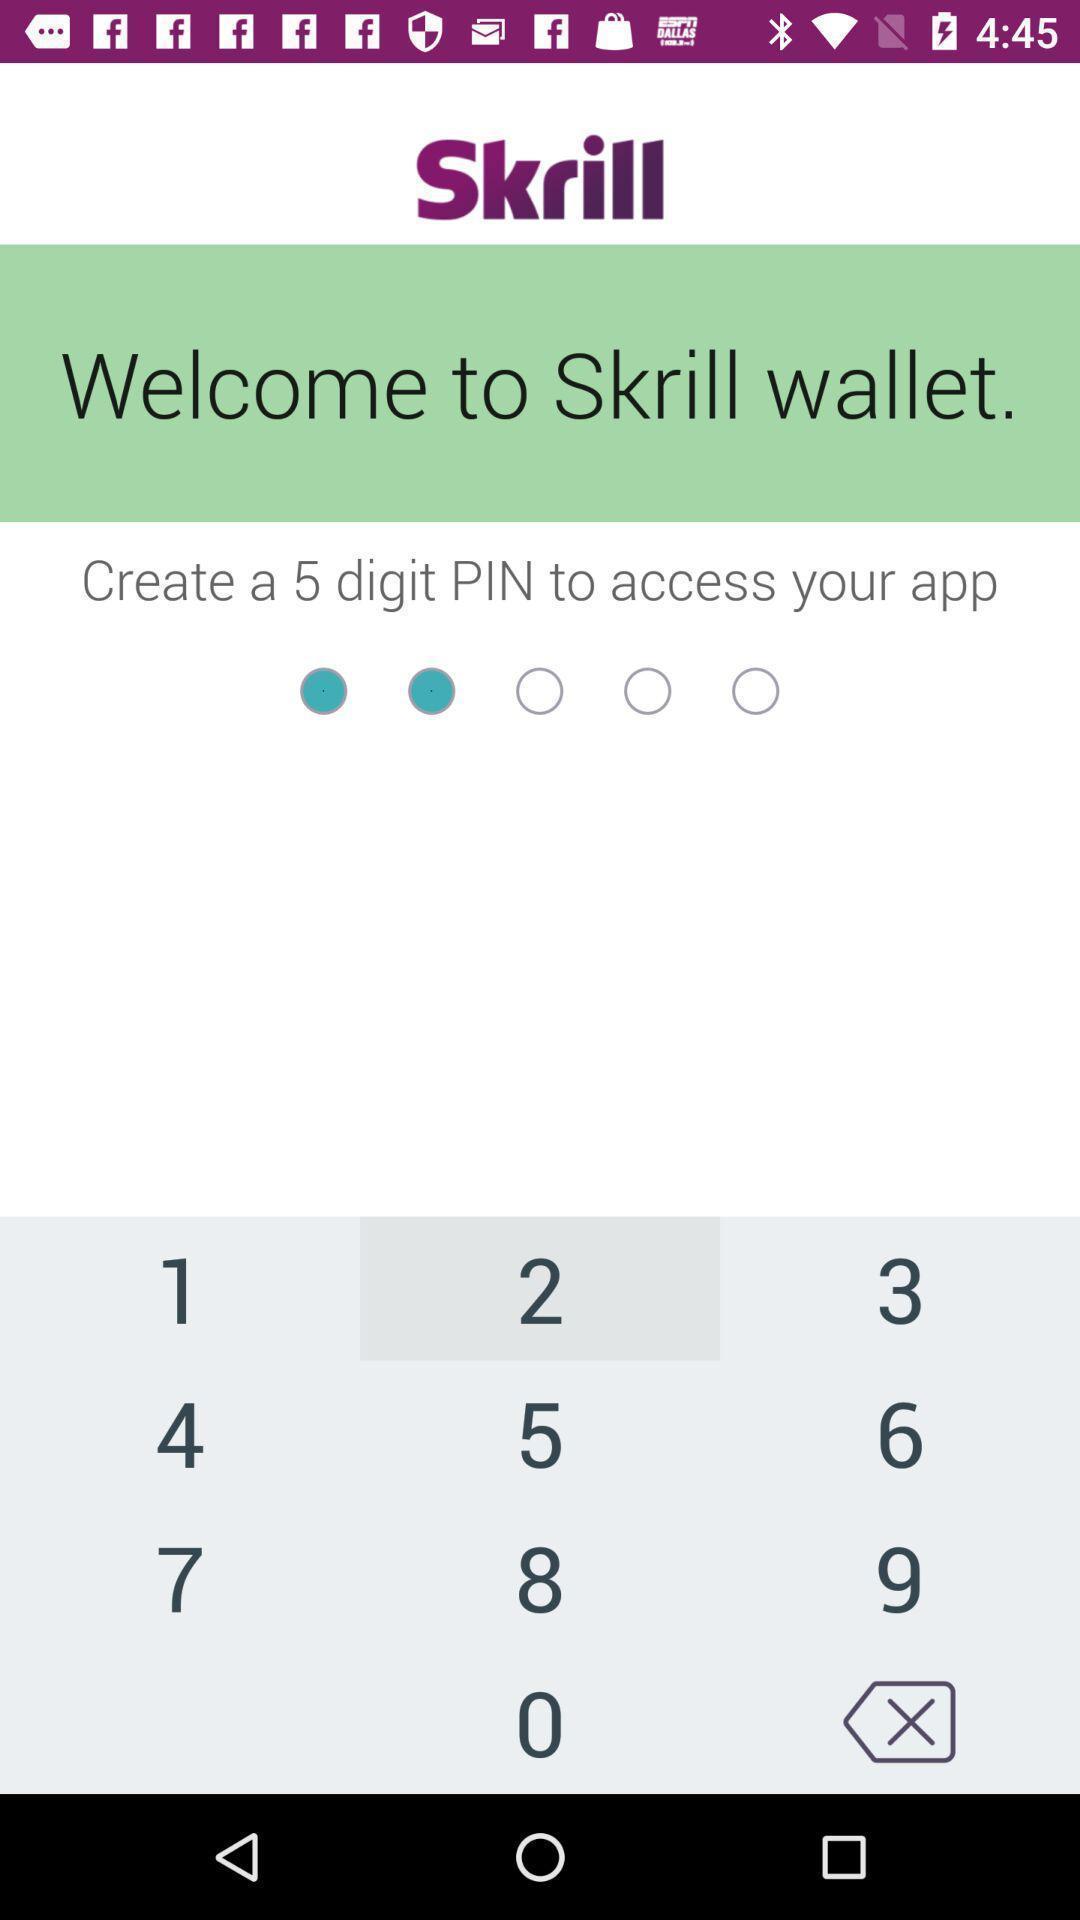Describe this image in words. Welcome page. 